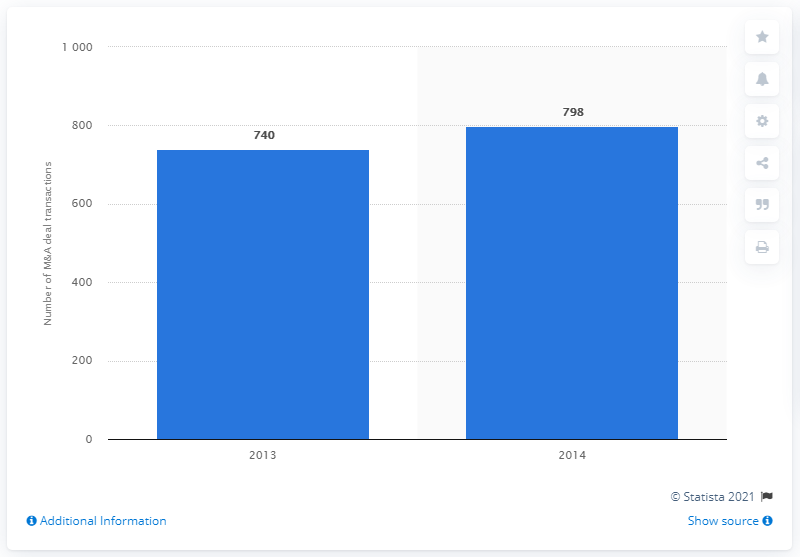What might be the implications of such an increase in merger and acquisition activities? An increase in merger and acquisition activities, like the one seen from 740 to 798 deals from 2013 to 2014, typically suggests a robust economic environment or sectors undergoing consolidation. This can lead to changes in market dynamics, such as increased market share and competitiveness for the merged entities, and possibly reduced competition in the market. Could this trend affect small businesses in the industry? Yes, a rise in mergers and acquisitions often poses challenges for small businesses. These can include increased market domination by larger companies, higher barriers to entry, and pressures on prices and supplies. Small businesses may need to adapt through strategies like niching down, enhancing service quality, or forming alliances. 